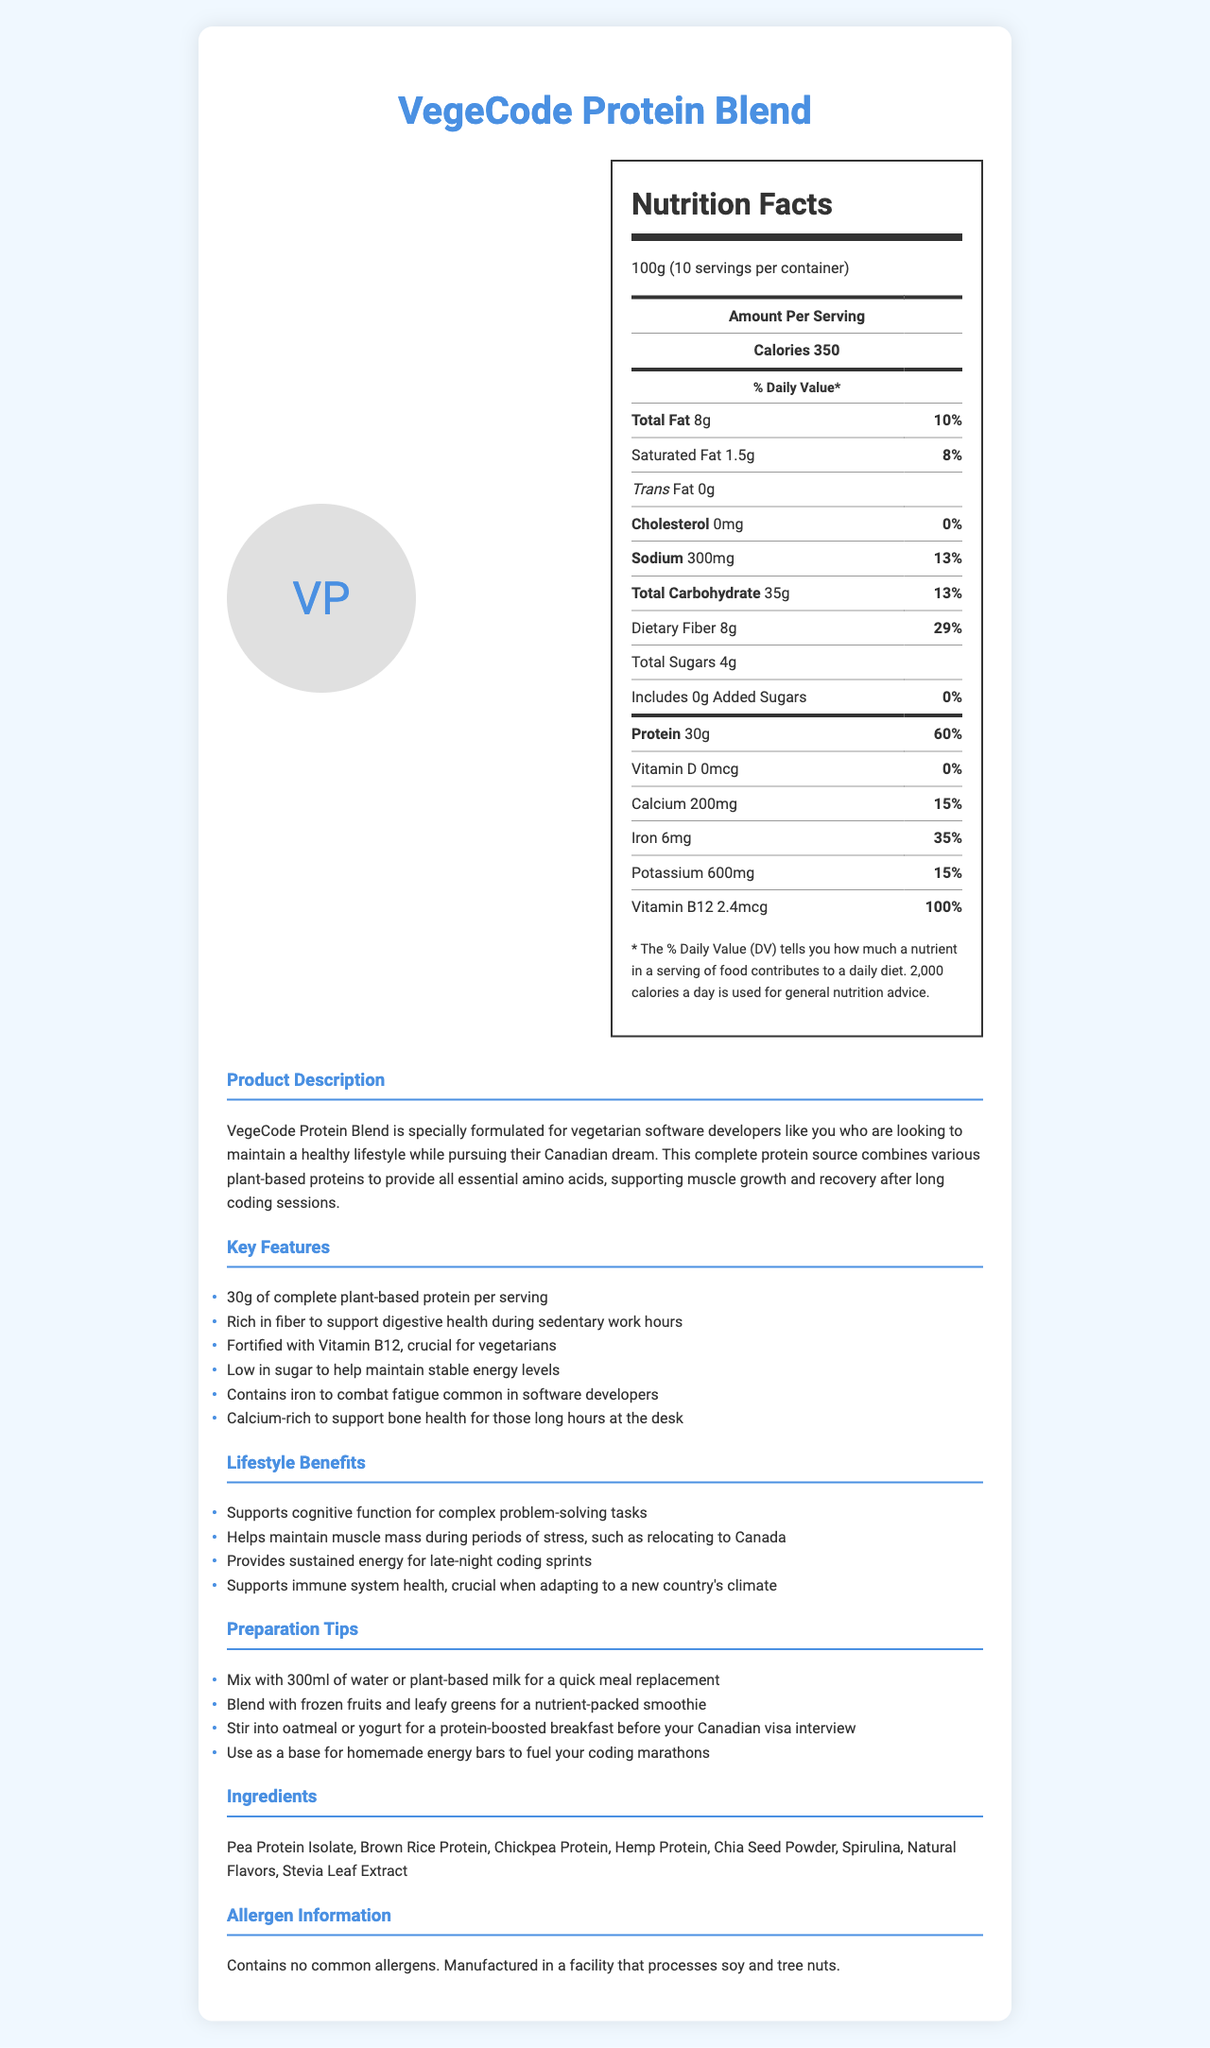What is the serving size of the VegeCode Protein Blend? The document specifies that the serving size is 100g.
Answer: 100g How many grams of protein are in each serving? The nutrition facts label shows that each serving contains 30g of protein.
Answer: 30g What is the total fat content per serving? The total fat amount is listed as 8g per serving.
Answer: 8g How much Vitamin B12 does a serving provide? The amount of Vitamin B12 in each serving is shown as 2.4mcg.
Answer: 2.4mcg Which ingredient is not a source of protein in the VegeCode blend? The list of ingredients includes several protein sources, but 'Natural Flavors' is not a protein source.
Answer: Natural Flavors What percentage of the daily value of dietary fiber does one serving provide? The nutrition facts indicate that the dietary fiber provides 29% of the daily value.
Answer: 29% How many servings are there in one container? The document mentions that there are 10 servings per container.
Answer: 10 servings What is the main purpose of this product according to the description? The product description mentions that VegeCode Protein Blend is formulated for vegetarian software developers looking to maintain a healthy lifestyle.
Answer: To support a healthy lifestyle for vegetarian software developers Which of the following is not a key feature mentioned in the document? 
A. Contains caffeine 
B. Rich in fiber 
C. Fortified with Vitamin B12 The key features list does not mention caffeine.
Answer: A What is the daily value percentage of calcium in one serving? The nutrition facts show that one serving provides 15% of the daily value for calcium.
Answer: 15% Does the product contain any added sugars? The document specifies that there are no added sugars in the product.
Answer: No Describe the main idea of the document. The main idea centers around presenting the VegeCode Protein Blend as a suitable nutritional supplement for vegetarian software developers, emphasizing its complete protein content, essential nutrients, and tailored benefits for a sedentary work lifestyle.
Answer: The document provides detailed nutrition information and benefits of the VegeCode Protein Blend, a plant-based protein supplement designed for vegetarian software developers. It highlights the product's nutritional content, key features, lifestyle benefits, and preparation tips. Can you determine the country of origin of the VegeCode Protein Blend from the document? The document does not provide any information about the country of origin of the VegeCode Protein Blend.
Answer: Cannot be determined 